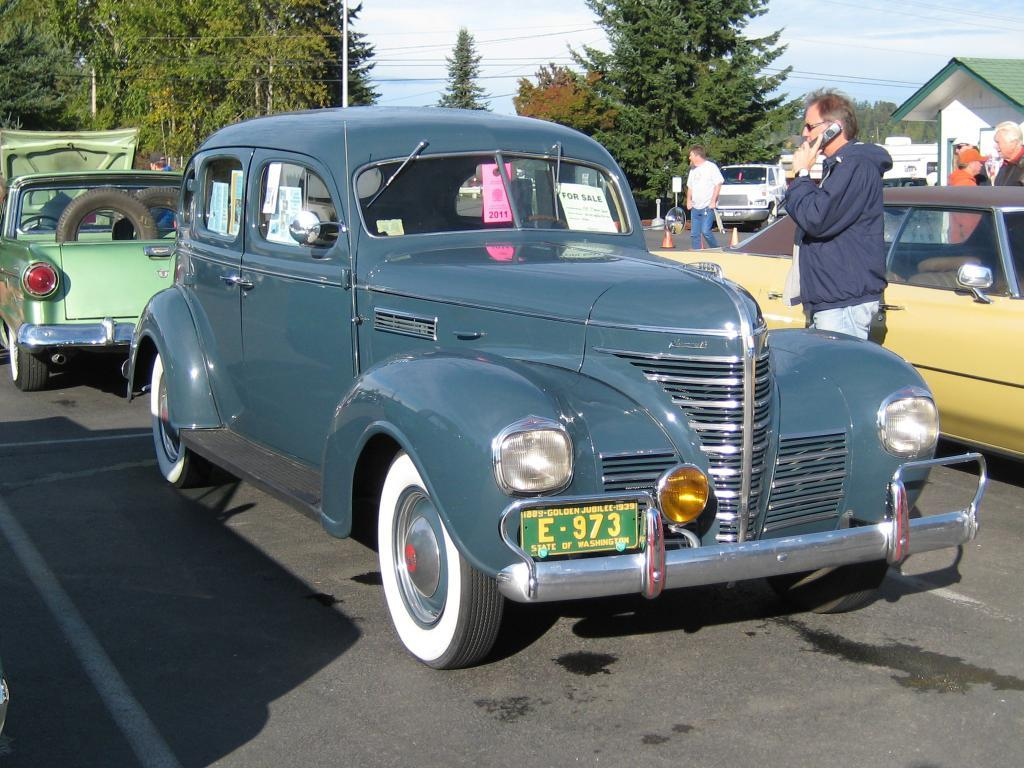What can be seen on the road in the image? There are vehicles on the road in the image. What else is present in the image besides the vehicles? There are people standing in the image. What can be seen in the distance in the image? There are trees and buildings in the background of the image. What type of reward is being given to the actor in the image? There is no actor or reward present in the image; it features vehicles on the road and people standing nearby. How many cherries are visible on the trees in the image? There are no cherries visible in the image; it only shows trees in the background. 